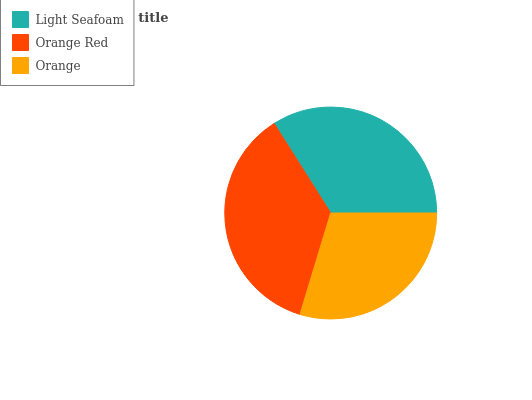Is Orange the minimum?
Answer yes or no. Yes. Is Orange Red the maximum?
Answer yes or no. Yes. Is Orange Red the minimum?
Answer yes or no. No. Is Orange the maximum?
Answer yes or no. No. Is Orange Red greater than Orange?
Answer yes or no. Yes. Is Orange less than Orange Red?
Answer yes or no. Yes. Is Orange greater than Orange Red?
Answer yes or no. No. Is Orange Red less than Orange?
Answer yes or no. No. Is Light Seafoam the high median?
Answer yes or no. Yes. Is Light Seafoam the low median?
Answer yes or no. Yes. Is Orange the high median?
Answer yes or no. No. Is Orange Red the low median?
Answer yes or no. No. 